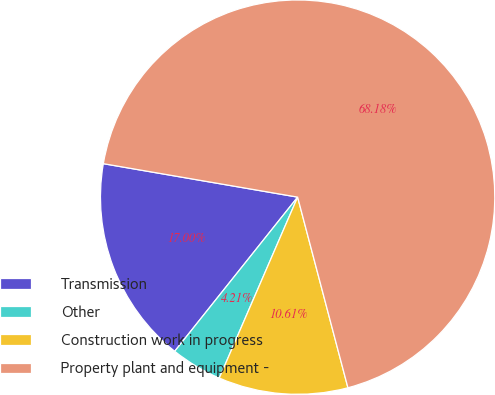Convert chart. <chart><loc_0><loc_0><loc_500><loc_500><pie_chart><fcel>Transmission<fcel>Other<fcel>Construction work in progress<fcel>Property plant and equipment -<nl><fcel>17.0%<fcel>4.21%<fcel>10.61%<fcel>68.18%<nl></chart> 